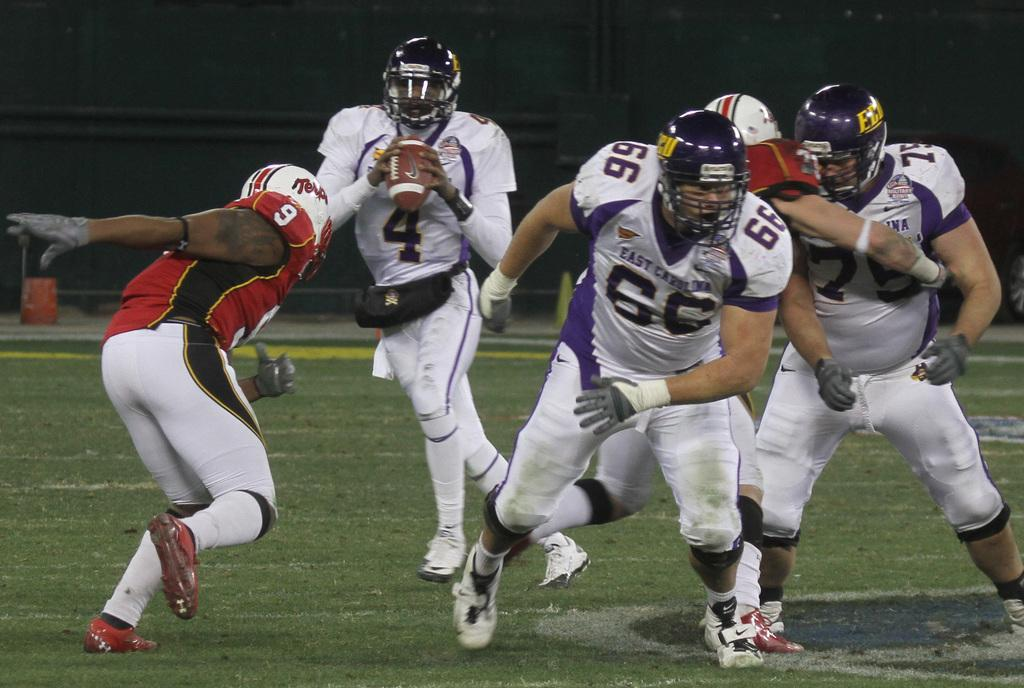What can be seen in the front portion of the image? There are people in the front portion of the image. What are the people wearing on their heads? The people are wearing helmets. What object is one person holding? One person is holding a ball. What type of vegetation covers the land in the image? The land is covered with grass. How would you describe the lighting in the background of the image? The background of the image is dark. What invention is being demonstrated by the people in the image? There is no invention being demonstrated in the image; the people are simply wearing helmets and holding a ball. How many wheels can be seen in the image? There are no wheels visible in the image. 